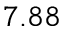Convert formula to latex. <formula><loc_0><loc_0><loc_500><loc_500>7 . 8 8</formula> 